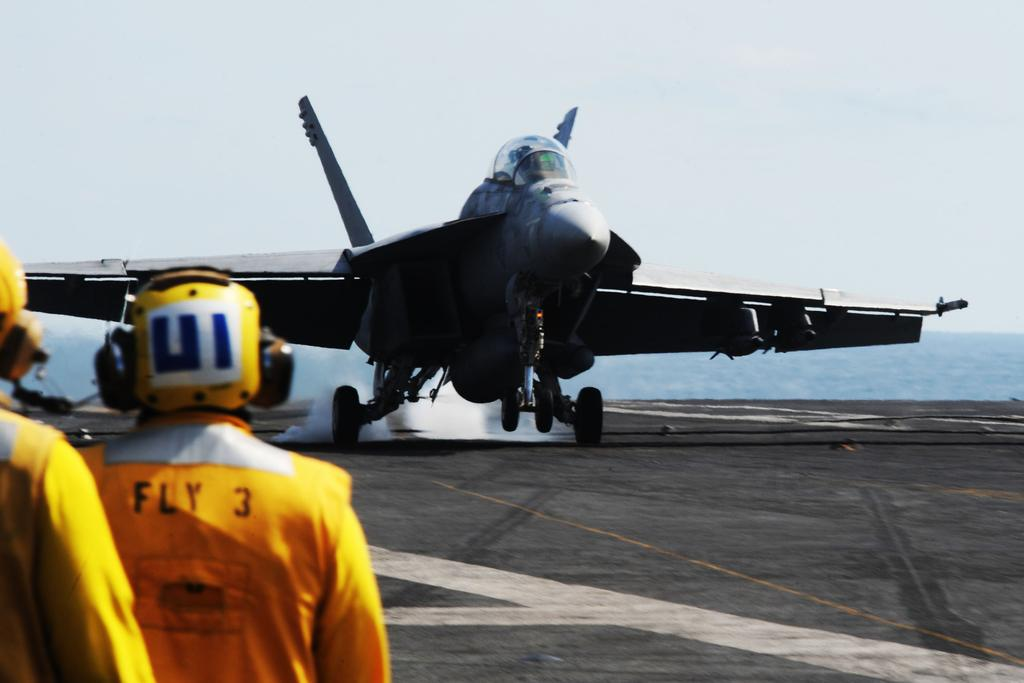<image>
Summarize the visual content of the image. Man in orange with "Fly 3" on his back watching a jet take off. 